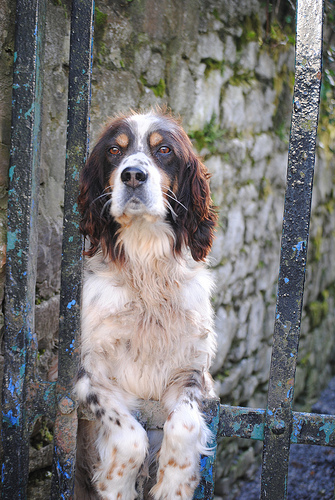<image>
Is there a dog under the stone? No. The dog is not positioned under the stone. The vertical relationship between these objects is different. Where is the dog head in relation to the grill? Is it in front of the grill? Yes. The dog head is positioned in front of the grill, appearing closer to the camera viewpoint. 